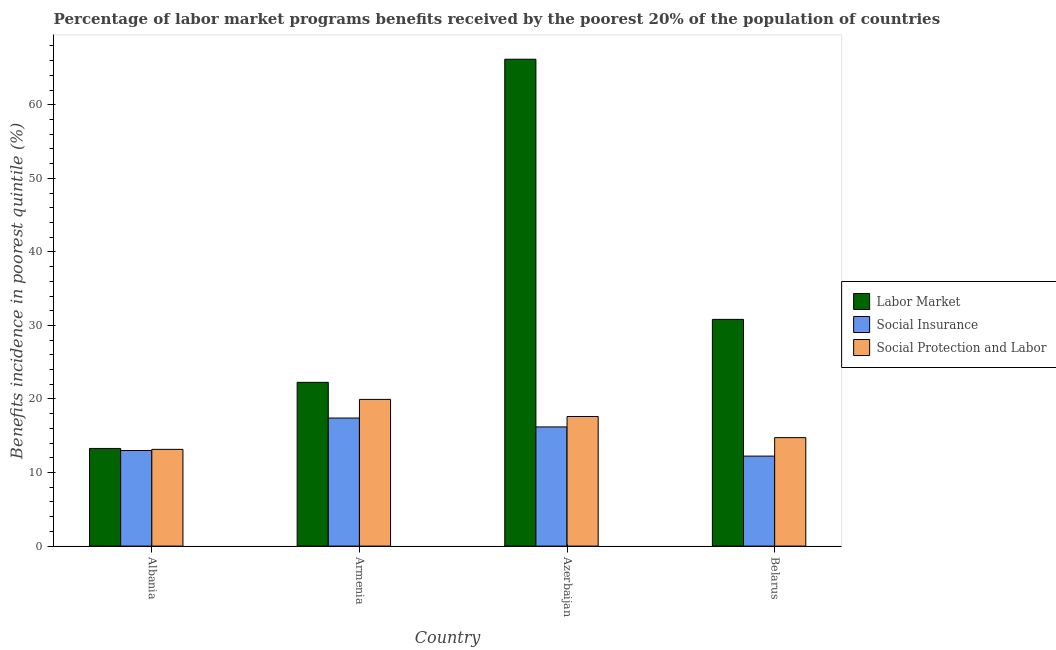How many different coloured bars are there?
Offer a terse response. 3. Are the number of bars on each tick of the X-axis equal?
Ensure brevity in your answer.  Yes. How many bars are there on the 2nd tick from the right?
Keep it short and to the point. 3. What is the label of the 4th group of bars from the left?
Provide a succinct answer. Belarus. What is the percentage of benefits received due to labor market programs in Armenia?
Offer a very short reply. 22.26. Across all countries, what is the maximum percentage of benefits received due to social insurance programs?
Keep it short and to the point. 17.41. Across all countries, what is the minimum percentage of benefits received due to labor market programs?
Your response must be concise. 13.28. In which country was the percentage of benefits received due to social insurance programs maximum?
Make the answer very short. Armenia. In which country was the percentage of benefits received due to social protection programs minimum?
Offer a terse response. Albania. What is the total percentage of benefits received due to social insurance programs in the graph?
Offer a very short reply. 58.85. What is the difference between the percentage of benefits received due to social insurance programs in Armenia and that in Azerbaijan?
Make the answer very short. 1.21. What is the difference between the percentage of benefits received due to social protection programs in Belarus and the percentage of benefits received due to social insurance programs in Azerbaijan?
Offer a terse response. -1.45. What is the average percentage of benefits received due to labor market programs per country?
Make the answer very short. 33.14. What is the difference between the percentage of benefits received due to labor market programs and percentage of benefits received due to social protection programs in Belarus?
Provide a succinct answer. 16.07. What is the ratio of the percentage of benefits received due to social protection programs in Azerbaijan to that in Belarus?
Your answer should be compact. 1.19. What is the difference between the highest and the second highest percentage of benefits received due to social protection programs?
Offer a very short reply. 2.33. What is the difference between the highest and the lowest percentage of benefits received due to labor market programs?
Make the answer very short. 52.92. Is the sum of the percentage of benefits received due to social insurance programs in Azerbaijan and Belarus greater than the maximum percentage of benefits received due to social protection programs across all countries?
Provide a short and direct response. Yes. What does the 2nd bar from the left in Belarus represents?
Your answer should be very brief. Social Insurance. What does the 1st bar from the right in Armenia represents?
Offer a very short reply. Social Protection and Labor. How many countries are there in the graph?
Keep it short and to the point. 4. What is the difference between two consecutive major ticks on the Y-axis?
Give a very brief answer. 10. Does the graph contain any zero values?
Make the answer very short. No. Where does the legend appear in the graph?
Keep it short and to the point. Center right. How are the legend labels stacked?
Make the answer very short. Vertical. What is the title of the graph?
Your answer should be compact. Percentage of labor market programs benefits received by the poorest 20% of the population of countries. Does "Non-communicable diseases" appear as one of the legend labels in the graph?
Your answer should be very brief. No. What is the label or title of the X-axis?
Your answer should be very brief. Country. What is the label or title of the Y-axis?
Your response must be concise. Benefits incidence in poorest quintile (%). What is the Benefits incidence in poorest quintile (%) in Labor Market in Albania?
Offer a very short reply. 13.28. What is the Benefits incidence in poorest quintile (%) in Social Insurance in Albania?
Your response must be concise. 13. What is the Benefits incidence in poorest quintile (%) of Social Protection and Labor in Albania?
Your answer should be very brief. 13.15. What is the Benefits incidence in poorest quintile (%) in Labor Market in Armenia?
Keep it short and to the point. 22.26. What is the Benefits incidence in poorest quintile (%) in Social Insurance in Armenia?
Give a very brief answer. 17.41. What is the Benefits incidence in poorest quintile (%) of Social Protection and Labor in Armenia?
Offer a terse response. 19.95. What is the Benefits incidence in poorest quintile (%) of Labor Market in Azerbaijan?
Provide a succinct answer. 66.19. What is the Benefits incidence in poorest quintile (%) of Social Insurance in Azerbaijan?
Offer a terse response. 16.2. What is the Benefits incidence in poorest quintile (%) of Social Protection and Labor in Azerbaijan?
Offer a very short reply. 17.62. What is the Benefits incidence in poorest quintile (%) of Labor Market in Belarus?
Your answer should be compact. 30.82. What is the Benefits incidence in poorest quintile (%) of Social Insurance in Belarus?
Your response must be concise. 12.24. What is the Benefits incidence in poorest quintile (%) in Social Protection and Labor in Belarus?
Provide a short and direct response. 14.75. Across all countries, what is the maximum Benefits incidence in poorest quintile (%) of Labor Market?
Offer a terse response. 66.19. Across all countries, what is the maximum Benefits incidence in poorest quintile (%) of Social Insurance?
Ensure brevity in your answer.  17.41. Across all countries, what is the maximum Benefits incidence in poorest quintile (%) of Social Protection and Labor?
Your answer should be compact. 19.95. Across all countries, what is the minimum Benefits incidence in poorest quintile (%) in Labor Market?
Keep it short and to the point. 13.28. Across all countries, what is the minimum Benefits incidence in poorest quintile (%) in Social Insurance?
Your response must be concise. 12.24. Across all countries, what is the minimum Benefits incidence in poorest quintile (%) of Social Protection and Labor?
Offer a terse response. 13.15. What is the total Benefits incidence in poorest quintile (%) in Labor Market in the graph?
Your answer should be compact. 132.55. What is the total Benefits incidence in poorest quintile (%) of Social Insurance in the graph?
Make the answer very short. 58.85. What is the total Benefits incidence in poorest quintile (%) in Social Protection and Labor in the graph?
Provide a short and direct response. 65.46. What is the difference between the Benefits incidence in poorest quintile (%) in Labor Market in Albania and that in Armenia?
Your answer should be very brief. -8.98. What is the difference between the Benefits incidence in poorest quintile (%) in Social Insurance in Albania and that in Armenia?
Provide a short and direct response. -4.41. What is the difference between the Benefits incidence in poorest quintile (%) of Social Protection and Labor in Albania and that in Armenia?
Provide a succinct answer. -6.79. What is the difference between the Benefits incidence in poorest quintile (%) in Labor Market in Albania and that in Azerbaijan?
Give a very brief answer. -52.92. What is the difference between the Benefits incidence in poorest quintile (%) in Social Insurance in Albania and that in Azerbaijan?
Provide a short and direct response. -3.21. What is the difference between the Benefits incidence in poorest quintile (%) of Social Protection and Labor in Albania and that in Azerbaijan?
Your response must be concise. -4.47. What is the difference between the Benefits incidence in poorest quintile (%) of Labor Market in Albania and that in Belarus?
Provide a succinct answer. -17.55. What is the difference between the Benefits incidence in poorest quintile (%) of Social Insurance in Albania and that in Belarus?
Offer a terse response. 0.76. What is the difference between the Benefits incidence in poorest quintile (%) of Social Protection and Labor in Albania and that in Belarus?
Ensure brevity in your answer.  -1.6. What is the difference between the Benefits incidence in poorest quintile (%) in Labor Market in Armenia and that in Azerbaijan?
Your response must be concise. -43.93. What is the difference between the Benefits incidence in poorest quintile (%) of Social Insurance in Armenia and that in Azerbaijan?
Provide a succinct answer. 1.21. What is the difference between the Benefits incidence in poorest quintile (%) of Social Protection and Labor in Armenia and that in Azerbaijan?
Ensure brevity in your answer.  2.33. What is the difference between the Benefits incidence in poorest quintile (%) in Labor Market in Armenia and that in Belarus?
Your answer should be compact. -8.56. What is the difference between the Benefits incidence in poorest quintile (%) in Social Insurance in Armenia and that in Belarus?
Ensure brevity in your answer.  5.17. What is the difference between the Benefits incidence in poorest quintile (%) in Social Protection and Labor in Armenia and that in Belarus?
Your response must be concise. 5.2. What is the difference between the Benefits incidence in poorest quintile (%) in Labor Market in Azerbaijan and that in Belarus?
Ensure brevity in your answer.  35.37. What is the difference between the Benefits incidence in poorest quintile (%) of Social Insurance in Azerbaijan and that in Belarus?
Give a very brief answer. 3.97. What is the difference between the Benefits incidence in poorest quintile (%) in Social Protection and Labor in Azerbaijan and that in Belarus?
Offer a terse response. 2.87. What is the difference between the Benefits incidence in poorest quintile (%) in Labor Market in Albania and the Benefits incidence in poorest quintile (%) in Social Insurance in Armenia?
Give a very brief answer. -4.13. What is the difference between the Benefits incidence in poorest quintile (%) in Labor Market in Albania and the Benefits incidence in poorest quintile (%) in Social Protection and Labor in Armenia?
Your response must be concise. -6.67. What is the difference between the Benefits incidence in poorest quintile (%) in Social Insurance in Albania and the Benefits incidence in poorest quintile (%) in Social Protection and Labor in Armenia?
Provide a short and direct response. -6.95. What is the difference between the Benefits incidence in poorest quintile (%) in Labor Market in Albania and the Benefits incidence in poorest quintile (%) in Social Insurance in Azerbaijan?
Keep it short and to the point. -2.93. What is the difference between the Benefits incidence in poorest quintile (%) of Labor Market in Albania and the Benefits incidence in poorest quintile (%) of Social Protection and Labor in Azerbaijan?
Offer a very short reply. -4.34. What is the difference between the Benefits incidence in poorest quintile (%) in Social Insurance in Albania and the Benefits incidence in poorest quintile (%) in Social Protection and Labor in Azerbaijan?
Provide a succinct answer. -4.62. What is the difference between the Benefits incidence in poorest quintile (%) of Labor Market in Albania and the Benefits incidence in poorest quintile (%) of Social Insurance in Belarus?
Your answer should be compact. 1.04. What is the difference between the Benefits incidence in poorest quintile (%) in Labor Market in Albania and the Benefits incidence in poorest quintile (%) in Social Protection and Labor in Belarus?
Keep it short and to the point. -1.47. What is the difference between the Benefits incidence in poorest quintile (%) in Social Insurance in Albania and the Benefits incidence in poorest quintile (%) in Social Protection and Labor in Belarus?
Give a very brief answer. -1.75. What is the difference between the Benefits incidence in poorest quintile (%) in Labor Market in Armenia and the Benefits incidence in poorest quintile (%) in Social Insurance in Azerbaijan?
Offer a terse response. 6.06. What is the difference between the Benefits incidence in poorest quintile (%) of Labor Market in Armenia and the Benefits incidence in poorest quintile (%) of Social Protection and Labor in Azerbaijan?
Keep it short and to the point. 4.64. What is the difference between the Benefits incidence in poorest quintile (%) of Social Insurance in Armenia and the Benefits incidence in poorest quintile (%) of Social Protection and Labor in Azerbaijan?
Provide a short and direct response. -0.21. What is the difference between the Benefits incidence in poorest quintile (%) of Labor Market in Armenia and the Benefits incidence in poorest quintile (%) of Social Insurance in Belarus?
Your answer should be very brief. 10.03. What is the difference between the Benefits incidence in poorest quintile (%) in Labor Market in Armenia and the Benefits incidence in poorest quintile (%) in Social Protection and Labor in Belarus?
Offer a very short reply. 7.51. What is the difference between the Benefits incidence in poorest quintile (%) in Social Insurance in Armenia and the Benefits incidence in poorest quintile (%) in Social Protection and Labor in Belarus?
Offer a terse response. 2.66. What is the difference between the Benefits incidence in poorest quintile (%) of Labor Market in Azerbaijan and the Benefits incidence in poorest quintile (%) of Social Insurance in Belarus?
Your answer should be very brief. 53.96. What is the difference between the Benefits incidence in poorest quintile (%) in Labor Market in Azerbaijan and the Benefits incidence in poorest quintile (%) in Social Protection and Labor in Belarus?
Ensure brevity in your answer.  51.44. What is the difference between the Benefits incidence in poorest quintile (%) in Social Insurance in Azerbaijan and the Benefits incidence in poorest quintile (%) in Social Protection and Labor in Belarus?
Provide a short and direct response. 1.45. What is the average Benefits incidence in poorest quintile (%) of Labor Market per country?
Your answer should be compact. 33.14. What is the average Benefits incidence in poorest quintile (%) of Social Insurance per country?
Your answer should be very brief. 14.71. What is the average Benefits incidence in poorest quintile (%) of Social Protection and Labor per country?
Provide a succinct answer. 16.37. What is the difference between the Benefits incidence in poorest quintile (%) in Labor Market and Benefits incidence in poorest quintile (%) in Social Insurance in Albania?
Provide a succinct answer. 0.28. What is the difference between the Benefits incidence in poorest quintile (%) in Labor Market and Benefits incidence in poorest quintile (%) in Social Protection and Labor in Albania?
Make the answer very short. 0.13. What is the difference between the Benefits incidence in poorest quintile (%) of Social Insurance and Benefits incidence in poorest quintile (%) of Social Protection and Labor in Albania?
Your answer should be compact. -0.15. What is the difference between the Benefits incidence in poorest quintile (%) in Labor Market and Benefits incidence in poorest quintile (%) in Social Insurance in Armenia?
Provide a short and direct response. 4.85. What is the difference between the Benefits incidence in poorest quintile (%) of Labor Market and Benefits incidence in poorest quintile (%) of Social Protection and Labor in Armenia?
Provide a short and direct response. 2.32. What is the difference between the Benefits incidence in poorest quintile (%) of Social Insurance and Benefits incidence in poorest quintile (%) of Social Protection and Labor in Armenia?
Offer a very short reply. -2.53. What is the difference between the Benefits incidence in poorest quintile (%) in Labor Market and Benefits incidence in poorest quintile (%) in Social Insurance in Azerbaijan?
Give a very brief answer. 49.99. What is the difference between the Benefits incidence in poorest quintile (%) of Labor Market and Benefits incidence in poorest quintile (%) of Social Protection and Labor in Azerbaijan?
Offer a very short reply. 48.57. What is the difference between the Benefits incidence in poorest quintile (%) in Social Insurance and Benefits incidence in poorest quintile (%) in Social Protection and Labor in Azerbaijan?
Your response must be concise. -1.42. What is the difference between the Benefits incidence in poorest quintile (%) in Labor Market and Benefits incidence in poorest quintile (%) in Social Insurance in Belarus?
Give a very brief answer. 18.59. What is the difference between the Benefits incidence in poorest quintile (%) of Labor Market and Benefits incidence in poorest quintile (%) of Social Protection and Labor in Belarus?
Your answer should be very brief. 16.07. What is the difference between the Benefits incidence in poorest quintile (%) in Social Insurance and Benefits incidence in poorest quintile (%) in Social Protection and Labor in Belarus?
Offer a terse response. -2.51. What is the ratio of the Benefits incidence in poorest quintile (%) in Labor Market in Albania to that in Armenia?
Provide a succinct answer. 0.6. What is the ratio of the Benefits incidence in poorest quintile (%) of Social Insurance in Albania to that in Armenia?
Ensure brevity in your answer.  0.75. What is the ratio of the Benefits incidence in poorest quintile (%) in Social Protection and Labor in Albania to that in Armenia?
Ensure brevity in your answer.  0.66. What is the ratio of the Benefits incidence in poorest quintile (%) of Labor Market in Albania to that in Azerbaijan?
Your answer should be very brief. 0.2. What is the ratio of the Benefits incidence in poorest quintile (%) of Social Insurance in Albania to that in Azerbaijan?
Your response must be concise. 0.8. What is the ratio of the Benefits incidence in poorest quintile (%) of Social Protection and Labor in Albania to that in Azerbaijan?
Provide a short and direct response. 0.75. What is the ratio of the Benefits incidence in poorest quintile (%) in Labor Market in Albania to that in Belarus?
Your answer should be very brief. 0.43. What is the ratio of the Benefits incidence in poorest quintile (%) of Social Insurance in Albania to that in Belarus?
Ensure brevity in your answer.  1.06. What is the ratio of the Benefits incidence in poorest quintile (%) in Social Protection and Labor in Albania to that in Belarus?
Keep it short and to the point. 0.89. What is the ratio of the Benefits incidence in poorest quintile (%) of Labor Market in Armenia to that in Azerbaijan?
Keep it short and to the point. 0.34. What is the ratio of the Benefits incidence in poorest quintile (%) in Social Insurance in Armenia to that in Azerbaijan?
Keep it short and to the point. 1.07. What is the ratio of the Benefits incidence in poorest quintile (%) in Social Protection and Labor in Armenia to that in Azerbaijan?
Provide a succinct answer. 1.13. What is the ratio of the Benefits incidence in poorest quintile (%) in Labor Market in Armenia to that in Belarus?
Your response must be concise. 0.72. What is the ratio of the Benefits incidence in poorest quintile (%) of Social Insurance in Armenia to that in Belarus?
Offer a terse response. 1.42. What is the ratio of the Benefits incidence in poorest quintile (%) in Social Protection and Labor in Armenia to that in Belarus?
Provide a short and direct response. 1.35. What is the ratio of the Benefits incidence in poorest quintile (%) in Labor Market in Azerbaijan to that in Belarus?
Provide a succinct answer. 2.15. What is the ratio of the Benefits incidence in poorest quintile (%) in Social Insurance in Azerbaijan to that in Belarus?
Provide a succinct answer. 1.32. What is the ratio of the Benefits incidence in poorest quintile (%) in Social Protection and Labor in Azerbaijan to that in Belarus?
Give a very brief answer. 1.19. What is the difference between the highest and the second highest Benefits incidence in poorest quintile (%) of Labor Market?
Make the answer very short. 35.37. What is the difference between the highest and the second highest Benefits incidence in poorest quintile (%) of Social Insurance?
Offer a very short reply. 1.21. What is the difference between the highest and the second highest Benefits incidence in poorest quintile (%) of Social Protection and Labor?
Offer a very short reply. 2.33. What is the difference between the highest and the lowest Benefits incidence in poorest quintile (%) of Labor Market?
Offer a terse response. 52.92. What is the difference between the highest and the lowest Benefits incidence in poorest quintile (%) in Social Insurance?
Your answer should be compact. 5.17. What is the difference between the highest and the lowest Benefits incidence in poorest quintile (%) in Social Protection and Labor?
Your response must be concise. 6.79. 